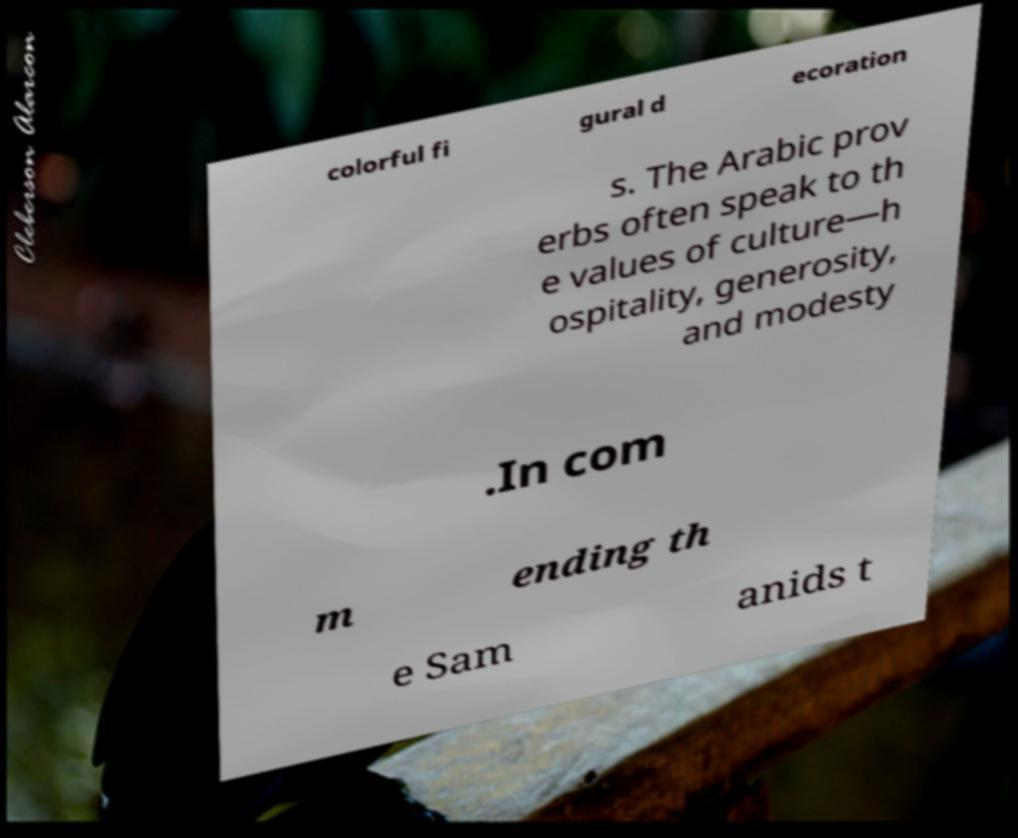Can you read and provide the text displayed in the image?This photo seems to have some interesting text. Can you extract and type it out for me? colorful fi gural d ecoration s. The Arabic prov erbs often speak to th e values of culture—h ospitality, generosity, and modesty .In com m ending th e Sam anids t 